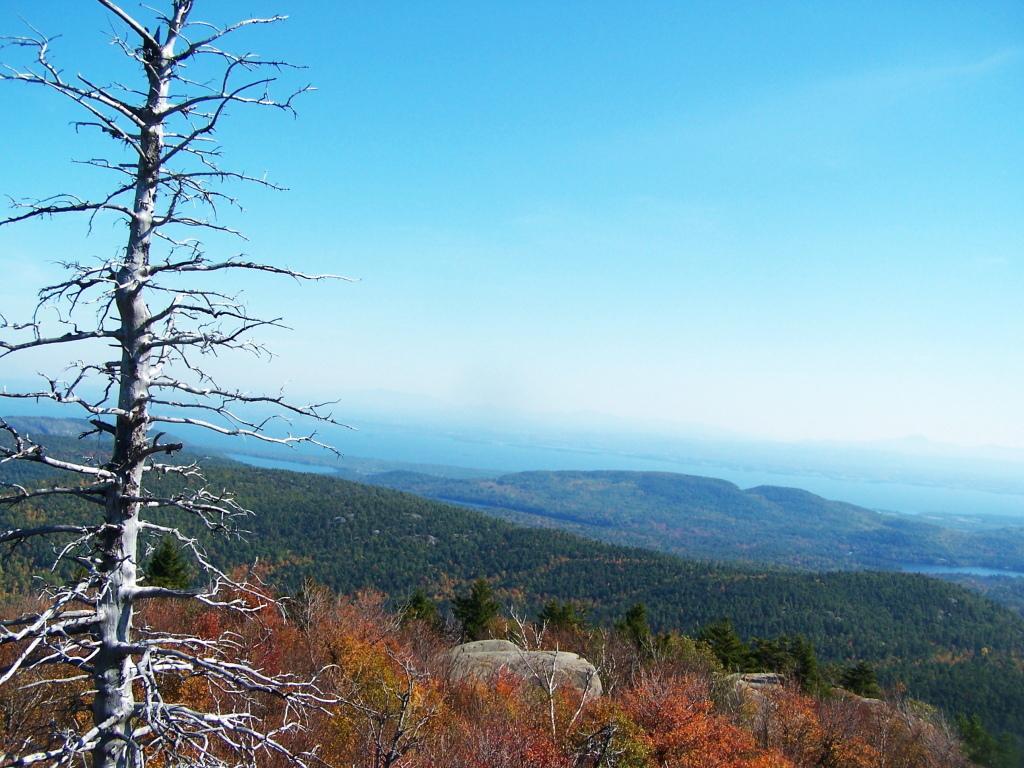Describe this image in one or two sentences. In this image I can see a dried tree on the left hand side of the image. I can see mountains and a lake in the center of the image. At the top of the image I can see the sky.  